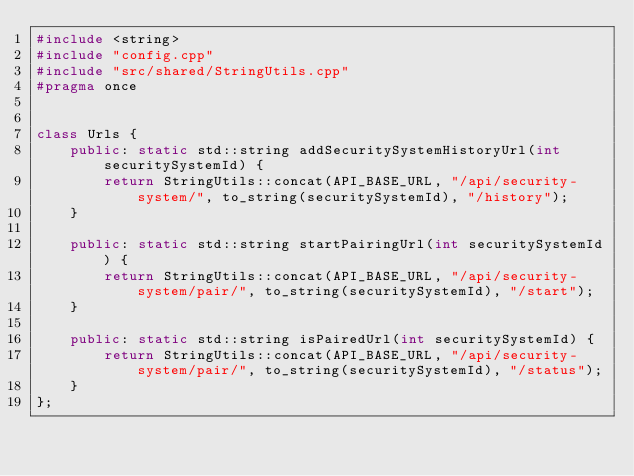Convert code to text. <code><loc_0><loc_0><loc_500><loc_500><_C++_>#include <string>
#include "config.cpp"
#include "src/shared/StringUtils.cpp"
#pragma once


class Urls {
    public: static std::string addSecuritySystemHistoryUrl(int securitySystemId) {
        return StringUtils::concat(API_BASE_URL, "/api/security-system/", to_string(securitySystemId), "/history");        
    }

    public: static std::string startPairingUrl(int securitySystemId) {
        return StringUtils::concat(API_BASE_URL, "/api/security-system/pair/", to_string(securitySystemId), "/start");        
    }

    public: static std::string isPairedUrl(int securitySystemId) {
        return StringUtils::concat(API_BASE_URL, "/api/security-system/pair/", to_string(securitySystemId), "/status");        
    }
};</code> 